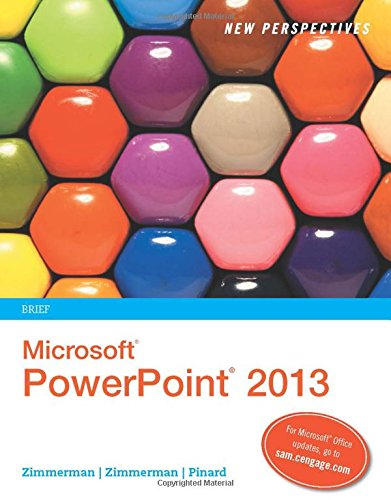How could this book be useful for a beginner in PowerPoint? The book serves as an excellent resource for beginners by introducing PowerPoint 2013's features in a structured manner, enhancing both basic understanding and the ability to create effective presentations. Does it include practical exercises? Yes, the book includes step-by-step tutorials and practice exercises that allow learners to apply what they've read, thereby solidifying their understanding of PowerPoint 2013. 